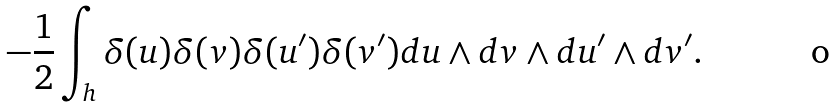Convert formula to latex. <formula><loc_0><loc_0><loc_500><loc_500>- \frac { 1 } { 2 } \int _ { h } \delta ( u ) \delta ( v ) \delta ( u ^ { \prime } ) \delta ( v ^ { \prime } ) d u \wedge d v \wedge d u ^ { \prime } \wedge d v ^ { \prime } .</formula> 